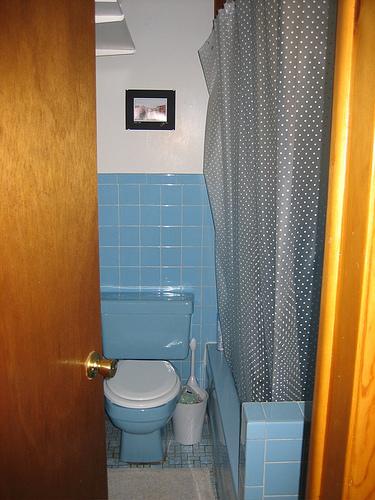Is the shower curtain open?
Answer briefly. No. What color are the tiles?
Answer briefly. Blue. Is the toilet seat up or down?
Concise answer only. Down. 